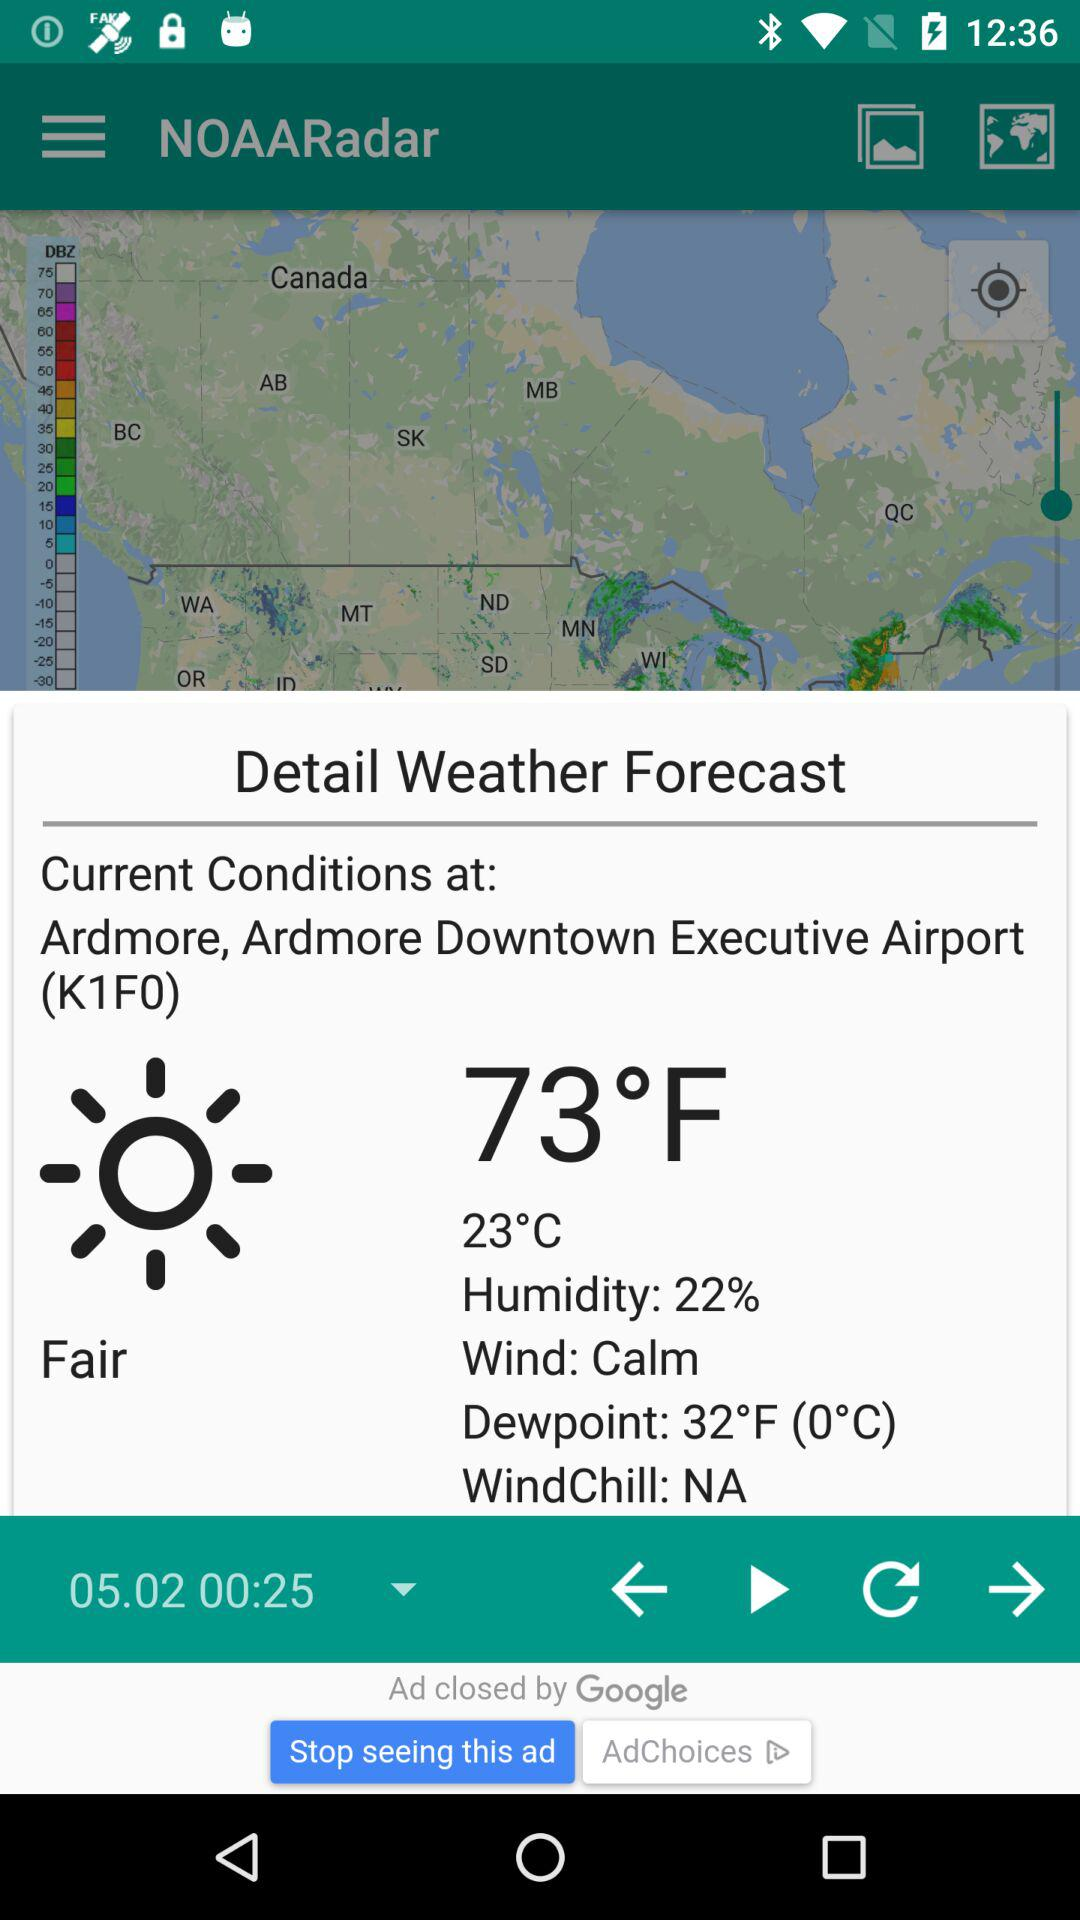What is the condition of the wind?
When the provided information is insufficient, respond with <no answer>. <no answer> 